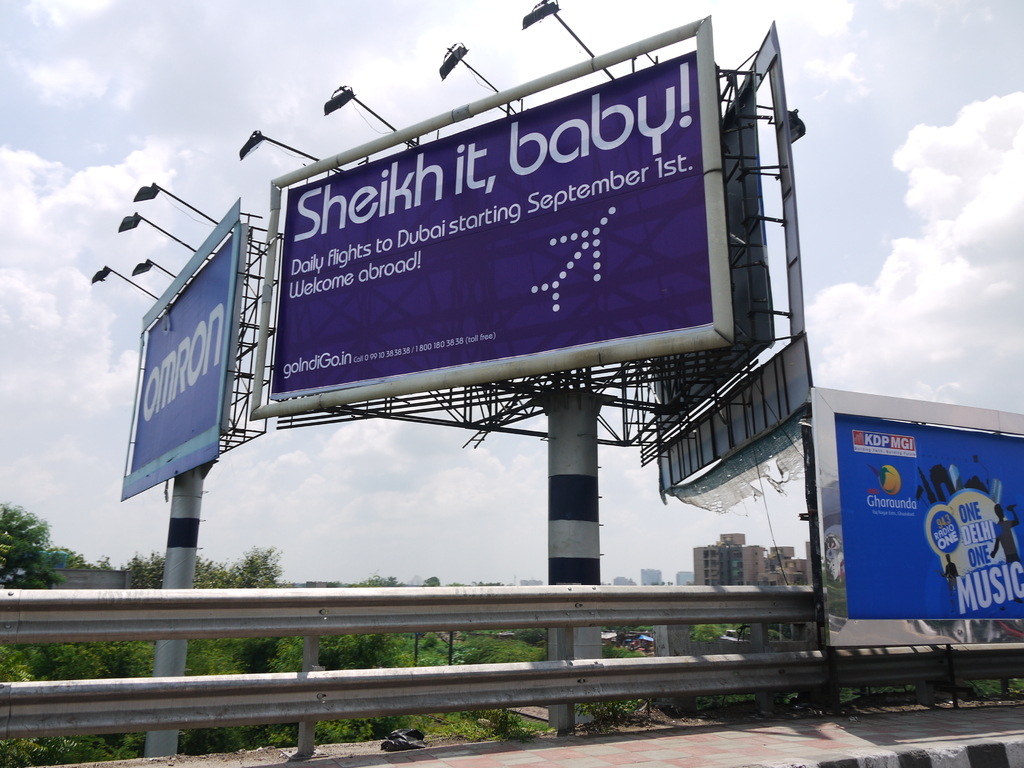Provide a one-sentence caption for the provided image. A vibrant purple billboard humorously promotes daily flights to Dubai with a catchy slogan 'Sheikh it, baby!', starting September 1st, aiming to attract travelers with its eye-catching design and welcoming message. 